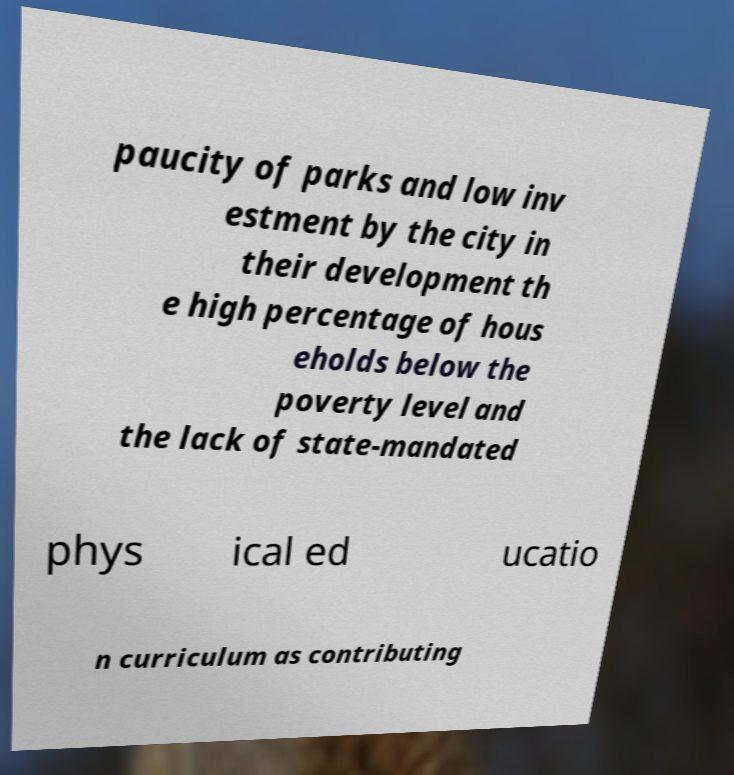There's text embedded in this image that I need extracted. Can you transcribe it verbatim? paucity of parks and low inv estment by the city in their development th e high percentage of hous eholds below the poverty level and the lack of state-mandated phys ical ed ucatio n curriculum as contributing 